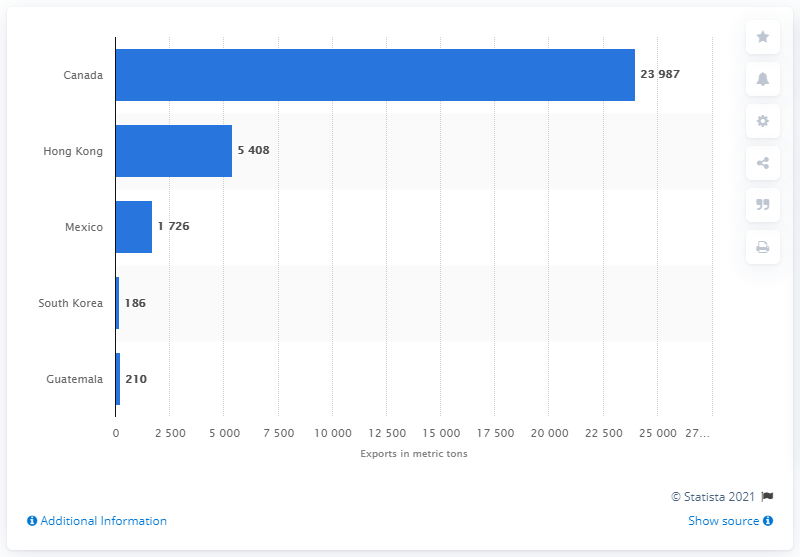Indicate a few pertinent items in this graphic. In 2019, Hong Kong was the second largest exporter of beef and veal in the world. 